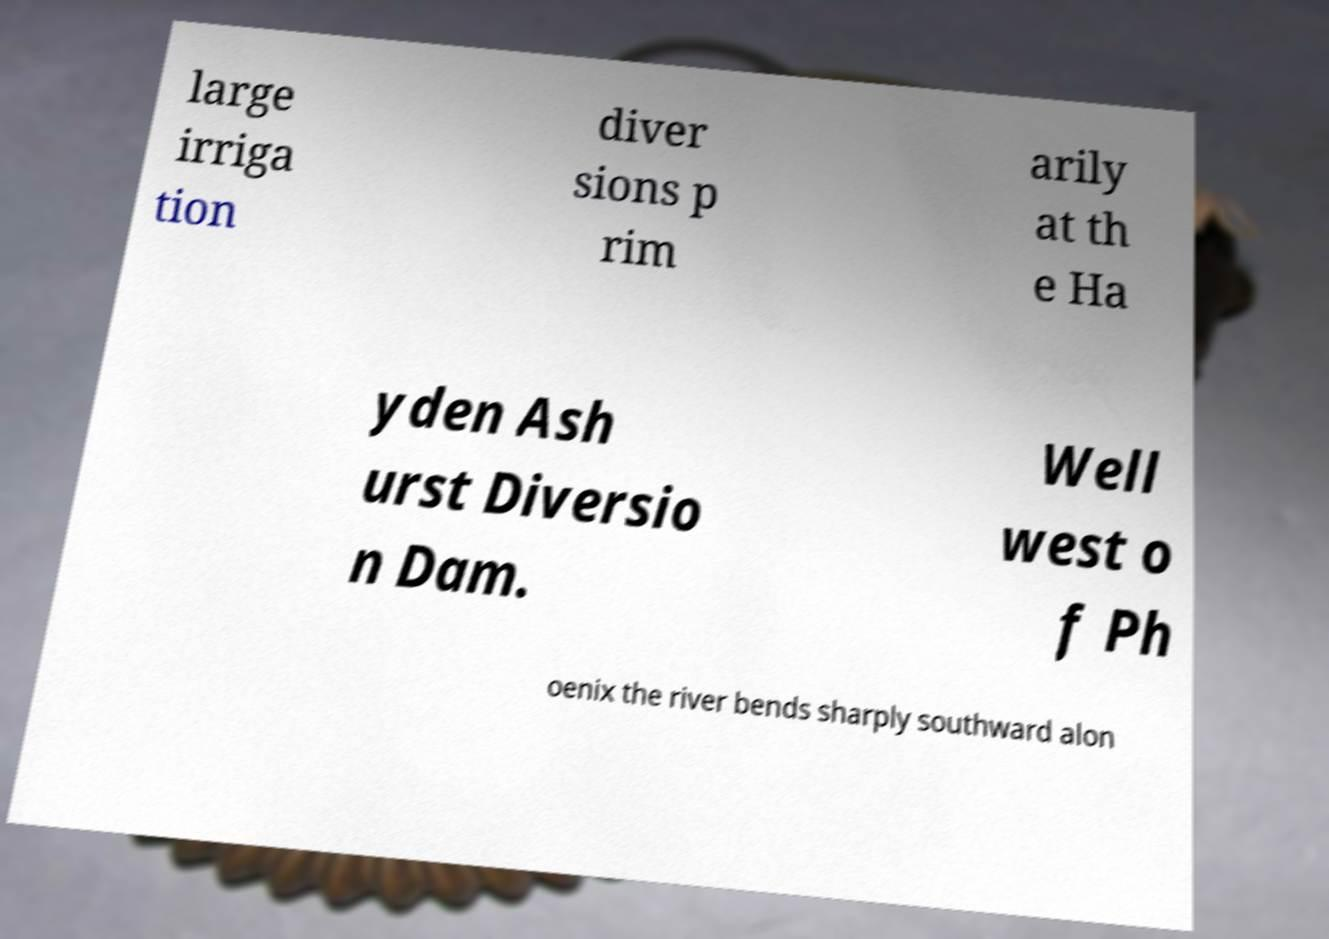For documentation purposes, I need the text within this image transcribed. Could you provide that? large irriga tion diver sions p rim arily at th e Ha yden Ash urst Diversio n Dam. Well west o f Ph oenix the river bends sharply southward alon 